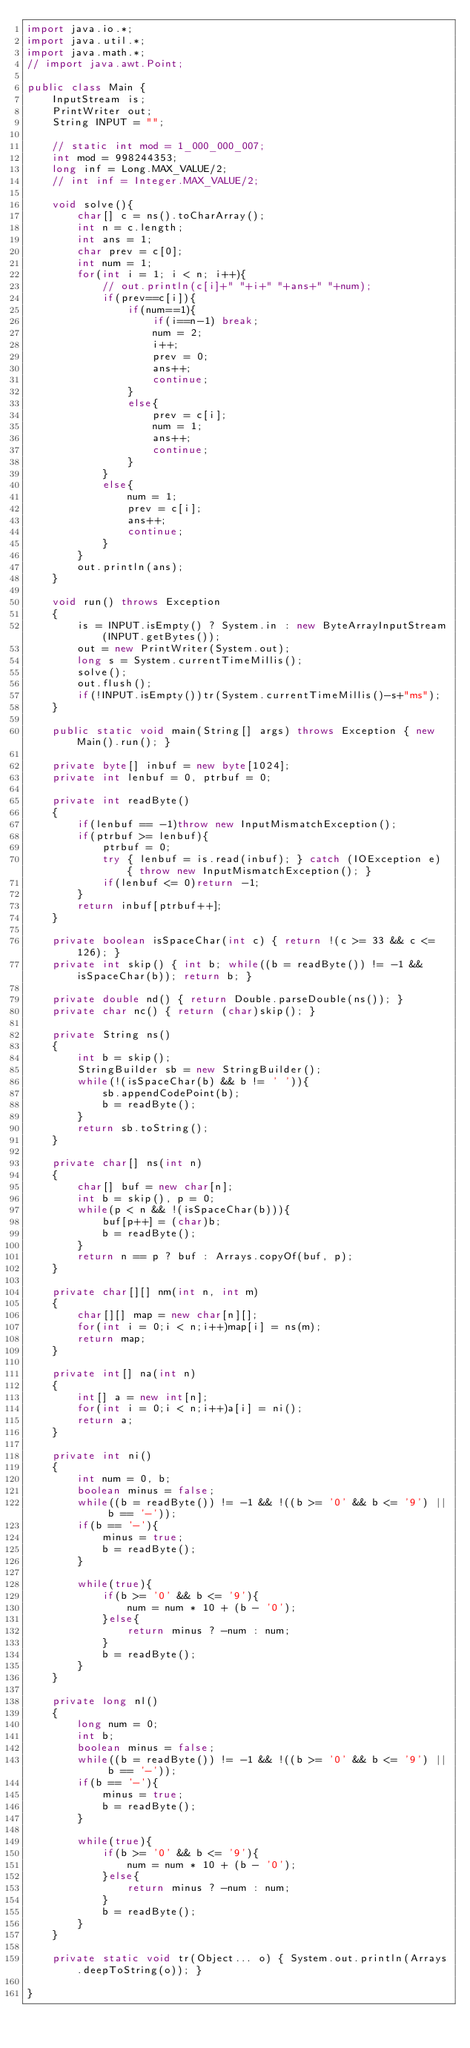Convert code to text. <code><loc_0><loc_0><loc_500><loc_500><_Java_>import java.io.*;
import java.util.*;
import java.math.*;
// import java.awt.Point;
 
public class Main {
    InputStream is;
    PrintWriter out;
    String INPUT = "";
 
    // static int mod = 1_000_000_007;
    int mod = 998244353;
    long inf = Long.MAX_VALUE/2;
    // int inf = Integer.MAX_VALUE/2;

    void solve(){
        char[] c = ns().toCharArray();
        int n = c.length;
        int ans = 1;
        char prev = c[0];
        int num = 1;
        for(int i = 1; i < n; i++){
            // out.println(c[i]+" "+i+" "+ans+" "+num);
            if(prev==c[i]){
                if(num==1){
                    if(i==n-1) break;
                    num = 2;
                    i++;
                    prev = 0;
                    ans++;
                    continue;
                }
                else{
                    prev = c[i];
                    num = 1;
                    ans++;
                    continue;
                }
            }
            else{
                num = 1;
                prev = c[i];
                ans++;
                continue;
            }
        }
        out.println(ans);
    } 

    void run() throws Exception
    {
        is = INPUT.isEmpty() ? System.in : new ByteArrayInputStream(INPUT.getBytes());
        out = new PrintWriter(System.out);
        long s = System.currentTimeMillis();
        solve();
        out.flush();
        if(!INPUT.isEmpty())tr(System.currentTimeMillis()-s+"ms");
    }
    
    public static void main(String[] args) throws Exception { new Main().run(); }
    
    private byte[] inbuf = new byte[1024];
    private int lenbuf = 0, ptrbuf = 0;
    
    private int readByte()
    {
        if(lenbuf == -1)throw new InputMismatchException();
        if(ptrbuf >= lenbuf){
            ptrbuf = 0;
            try { lenbuf = is.read(inbuf); } catch (IOException e) { throw new InputMismatchException(); }
            if(lenbuf <= 0)return -1;
        }
        return inbuf[ptrbuf++];
    }
    
    private boolean isSpaceChar(int c) { return !(c >= 33 && c <= 126); }
    private int skip() { int b; while((b = readByte()) != -1 && isSpaceChar(b)); return b; }
    
    private double nd() { return Double.parseDouble(ns()); }
    private char nc() { return (char)skip(); }
    
    private String ns()
    {
        int b = skip();
        StringBuilder sb = new StringBuilder();
        while(!(isSpaceChar(b) && b != ' ')){
            sb.appendCodePoint(b);
            b = readByte();
        }
        return sb.toString();
    }
    
    private char[] ns(int n)
    {
        char[] buf = new char[n];
        int b = skip(), p = 0;
        while(p < n && !(isSpaceChar(b))){
            buf[p++] = (char)b;
            b = readByte();
        }
        return n == p ? buf : Arrays.copyOf(buf, p);
    }
    
    private char[][] nm(int n, int m)
    {
        char[][] map = new char[n][];
        for(int i = 0;i < n;i++)map[i] = ns(m);
        return map;
    }
    
    private int[] na(int n)
    {
        int[] a = new int[n];
        for(int i = 0;i < n;i++)a[i] = ni();
        return a;
    }
    
    private int ni()
    {
        int num = 0, b;
        boolean minus = false;
        while((b = readByte()) != -1 && !((b >= '0' && b <= '9') || b == '-'));
        if(b == '-'){
            minus = true;
            b = readByte();
        }
        
        while(true){
            if(b >= '0' && b <= '9'){
                num = num * 10 + (b - '0');
            }else{
                return minus ? -num : num;
            }
            b = readByte();
        }
    }
    
    private long nl()
    {
        long num = 0;
        int b;
        boolean minus = false;
        while((b = readByte()) != -1 && !((b >= '0' && b <= '9') || b == '-'));
        if(b == '-'){
            minus = true;
            b = readByte();
        }
        
        while(true){
            if(b >= '0' && b <= '9'){
                num = num * 10 + (b - '0');
            }else{
                return minus ? -num : num;
            }
            b = readByte();
        }
    }
    
    private static void tr(Object... o) { System.out.println(Arrays.deepToString(o)); }
 
}
</code> 